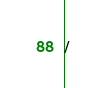Convert code to text. <code><loc_0><loc_0><loc_500><loc_500><_SQL_>/


</code> 